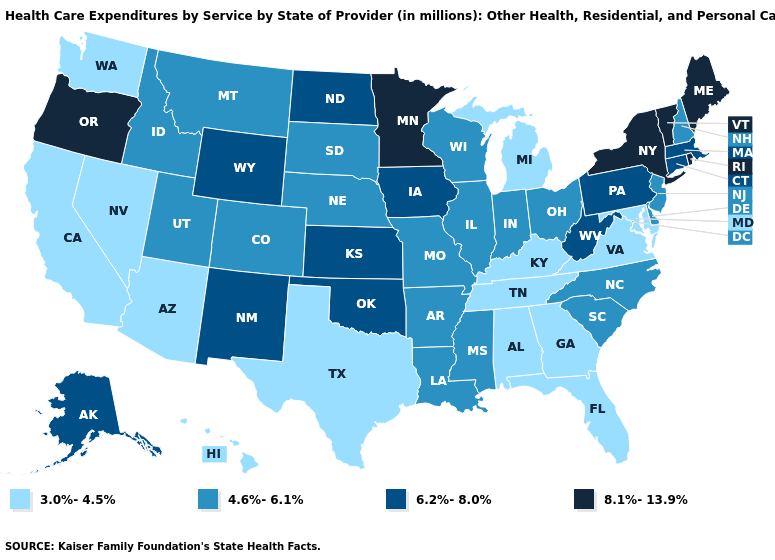Which states have the lowest value in the MidWest?
Write a very short answer. Michigan. What is the lowest value in the South?
Give a very brief answer. 3.0%-4.5%. Does the map have missing data?
Short answer required. No. Name the states that have a value in the range 6.2%-8.0%?
Concise answer only. Alaska, Connecticut, Iowa, Kansas, Massachusetts, New Mexico, North Dakota, Oklahoma, Pennsylvania, West Virginia, Wyoming. Name the states that have a value in the range 6.2%-8.0%?
Write a very short answer. Alaska, Connecticut, Iowa, Kansas, Massachusetts, New Mexico, North Dakota, Oklahoma, Pennsylvania, West Virginia, Wyoming. Which states have the lowest value in the USA?
Be succinct. Alabama, Arizona, California, Florida, Georgia, Hawaii, Kentucky, Maryland, Michigan, Nevada, Tennessee, Texas, Virginia, Washington. Name the states that have a value in the range 4.6%-6.1%?
Write a very short answer. Arkansas, Colorado, Delaware, Idaho, Illinois, Indiana, Louisiana, Mississippi, Missouri, Montana, Nebraska, New Hampshire, New Jersey, North Carolina, Ohio, South Carolina, South Dakota, Utah, Wisconsin. Does the map have missing data?
Write a very short answer. No. Is the legend a continuous bar?
Quick response, please. No. Name the states that have a value in the range 8.1%-13.9%?
Keep it brief. Maine, Minnesota, New York, Oregon, Rhode Island, Vermont. What is the lowest value in the MidWest?
Keep it brief. 3.0%-4.5%. Name the states that have a value in the range 6.2%-8.0%?
Be succinct. Alaska, Connecticut, Iowa, Kansas, Massachusetts, New Mexico, North Dakota, Oklahoma, Pennsylvania, West Virginia, Wyoming. What is the value of Wyoming?
Write a very short answer. 6.2%-8.0%. Does Idaho have a higher value than Georgia?
Answer briefly. Yes. Does the map have missing data?
Give a very brief answer. No. 